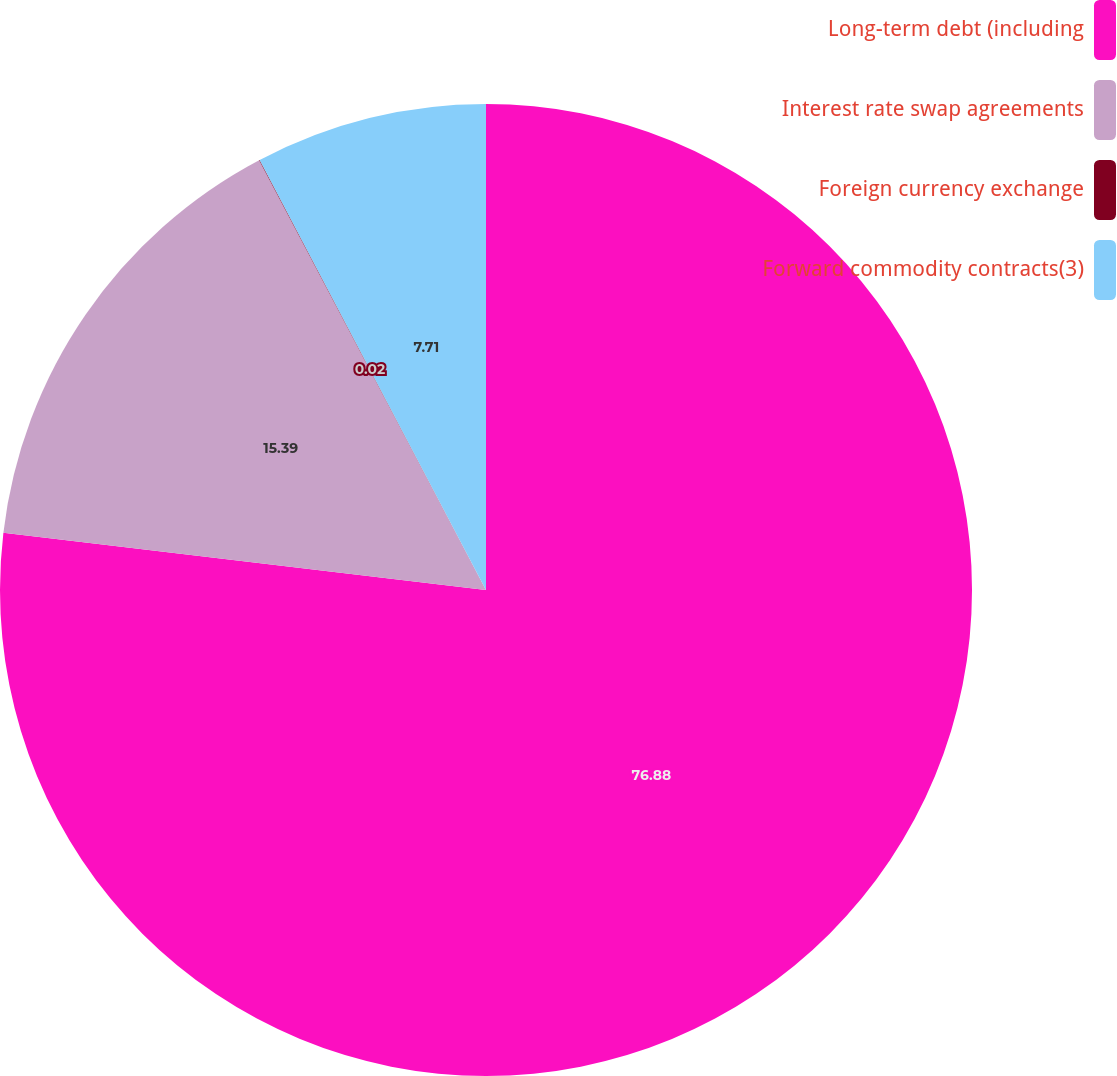Convert chart to OTSL. <chart><loc_0><loc_0><loc_500><loc_500><pie_chart><fcel>Long-term debt (including<fcel>Interest rate swap agreements<fcel>Foreign currency exchange<fcel>Forward commodity contracts(3)<nl><fcel>76.88%<fcel>15.39%<fcel>0.02%<fcel>7.71%<nl></chart> 